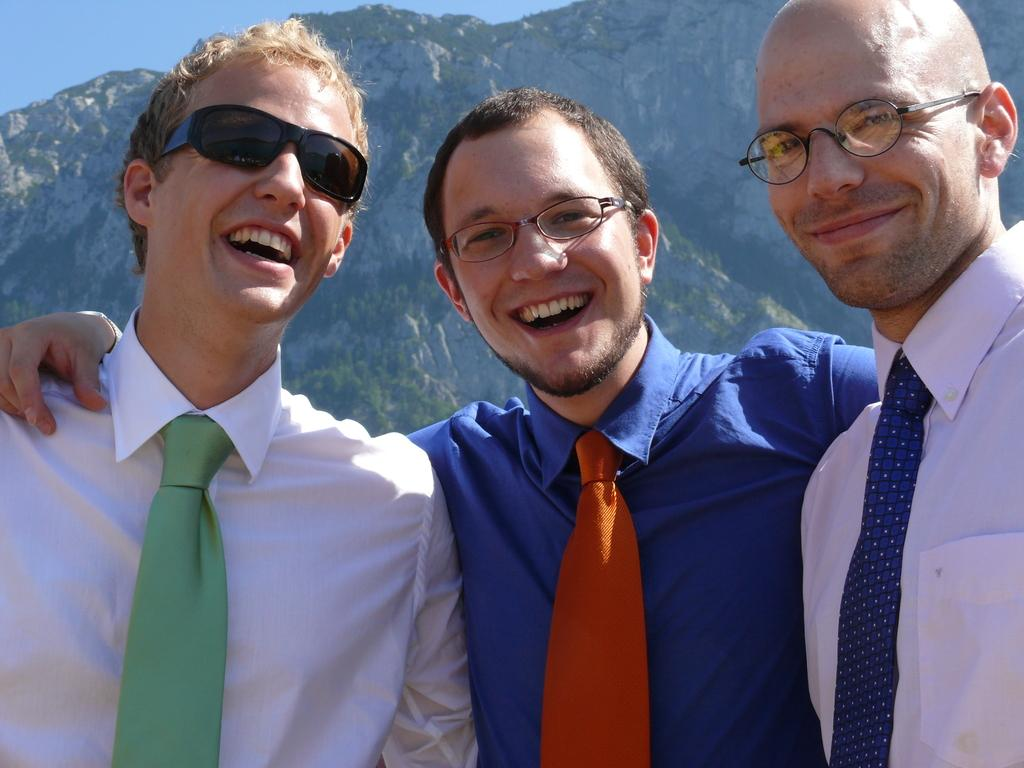How many people are present in the image? There are three people in the image. What are the people wearing on their faces? The people are wearing specs and goggles. What can be seen in the background of the image? There are mountains and the sky visible in the background of the image. What colors are the people wearing? The people are wearing different color dresses. Can you tell me how many yaks are grazing in the land behind the people? There are no yaks present in the image; the background features mountains and the sky. 